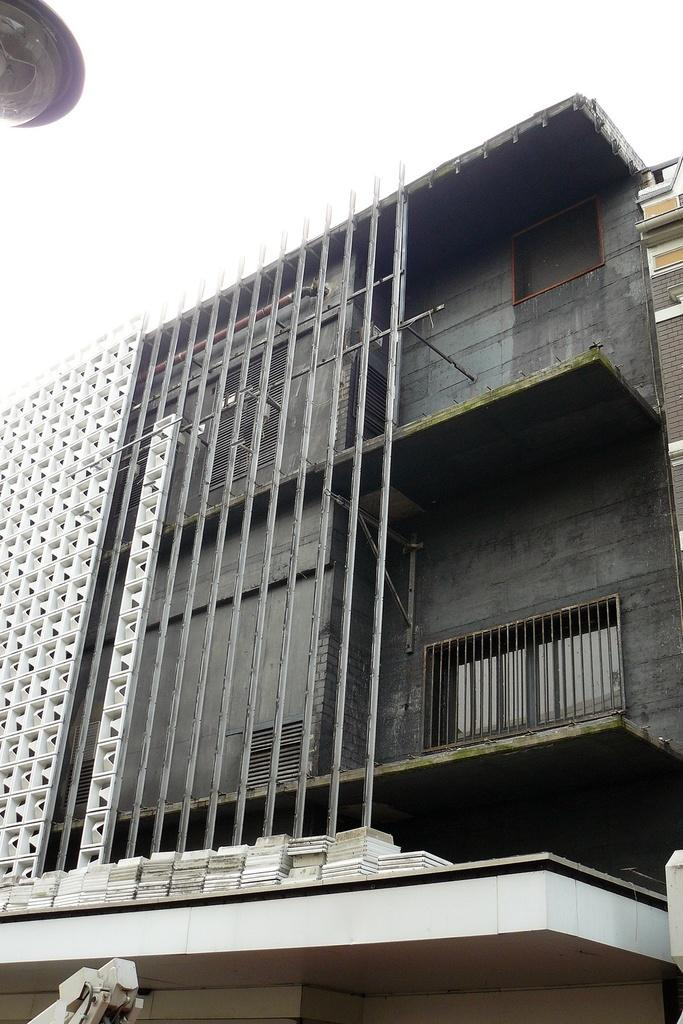What type of structure is present in the image? There is a building in the image. Can you describe the lighting conditions in the image? There is light visible in the image. What part of the natural environment is visible in the image? The sky is visible in the image. How many pears are hanging from the building in the image? There are no pears present in the image; it features a building with visible light and the sky. 